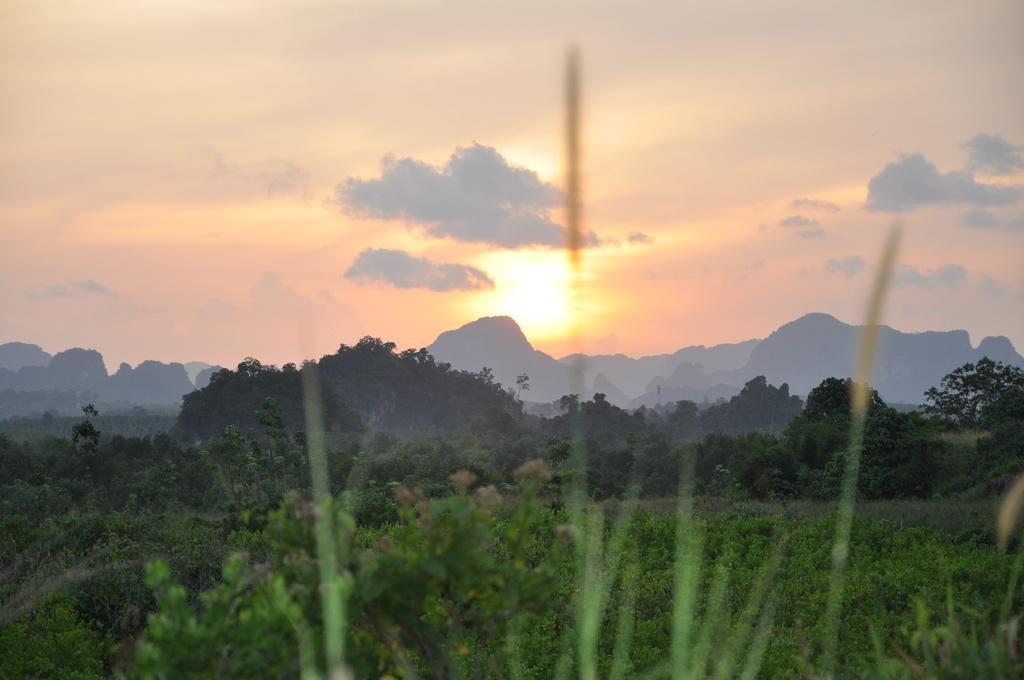Describe this image in one or two sentences. In this image there are plants, in the background there are trees, mountains and the sky. 